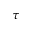<formula> <loc_0><loc_0><loc_500><loc_500>\tau</formula> 